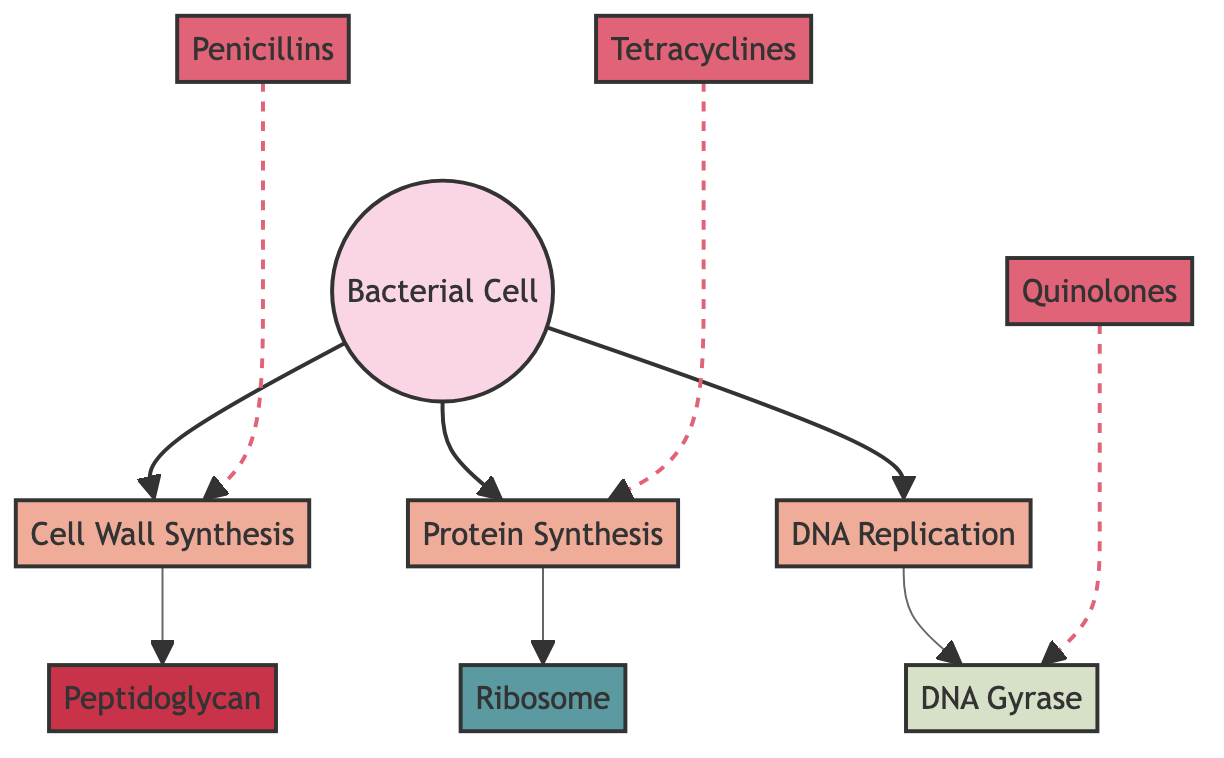What is the first mechanism of action shown in the diagram? The diagram begins with the node "Cell Wall Synthesis," which denotes the first mechanism of action that the antibiotics influence in the bacterial cell.
Answer: Cell Wall Synthesis How many classes of antibiotics are depicted in the diagram? The diagram shows three distinct classes of antibiotics: Penicillins, Tetracyclines, and Quinolones. Counting these, we arrive at a total of three classes.
Answer: 3 Which antibiotic class targets protein synthesis? In the diagram, "Tetracyclines" is the class that connects specifically to protein synthesis as depicted by the edge leading from the "Tetracyclines" node to the "Protein Synthesis" node.
Answer: Tetracyclines What relationship exists between Penicillins and Cell Wall Synthesis? The diagram illustrates a relationship where Penicillins are shown to act on both the "Cell Wall Synthesis" mechanism. This relationship is depicted with a dashed arrow, indicating the mechanism through which Penicillins exert their action.
Answer: Inhibition Which node represents the structure that is involved in DNA replication? The diagram specifies "DNA Gyrase" as the enzyme involved in the process of DNA replication. This node is distinctly connected to the "DNA Replication" mechanism.
Answer: DNA Gyrase What is the common structural feature shared by all antibiotics represented in the diagram? All antibiotic classes shown in the diagram target specific cellular mechanisms, which denotes their common functional characteristic as they inhibit different essential processes for bacterial growth.
Answer: Targeted mechanisms 